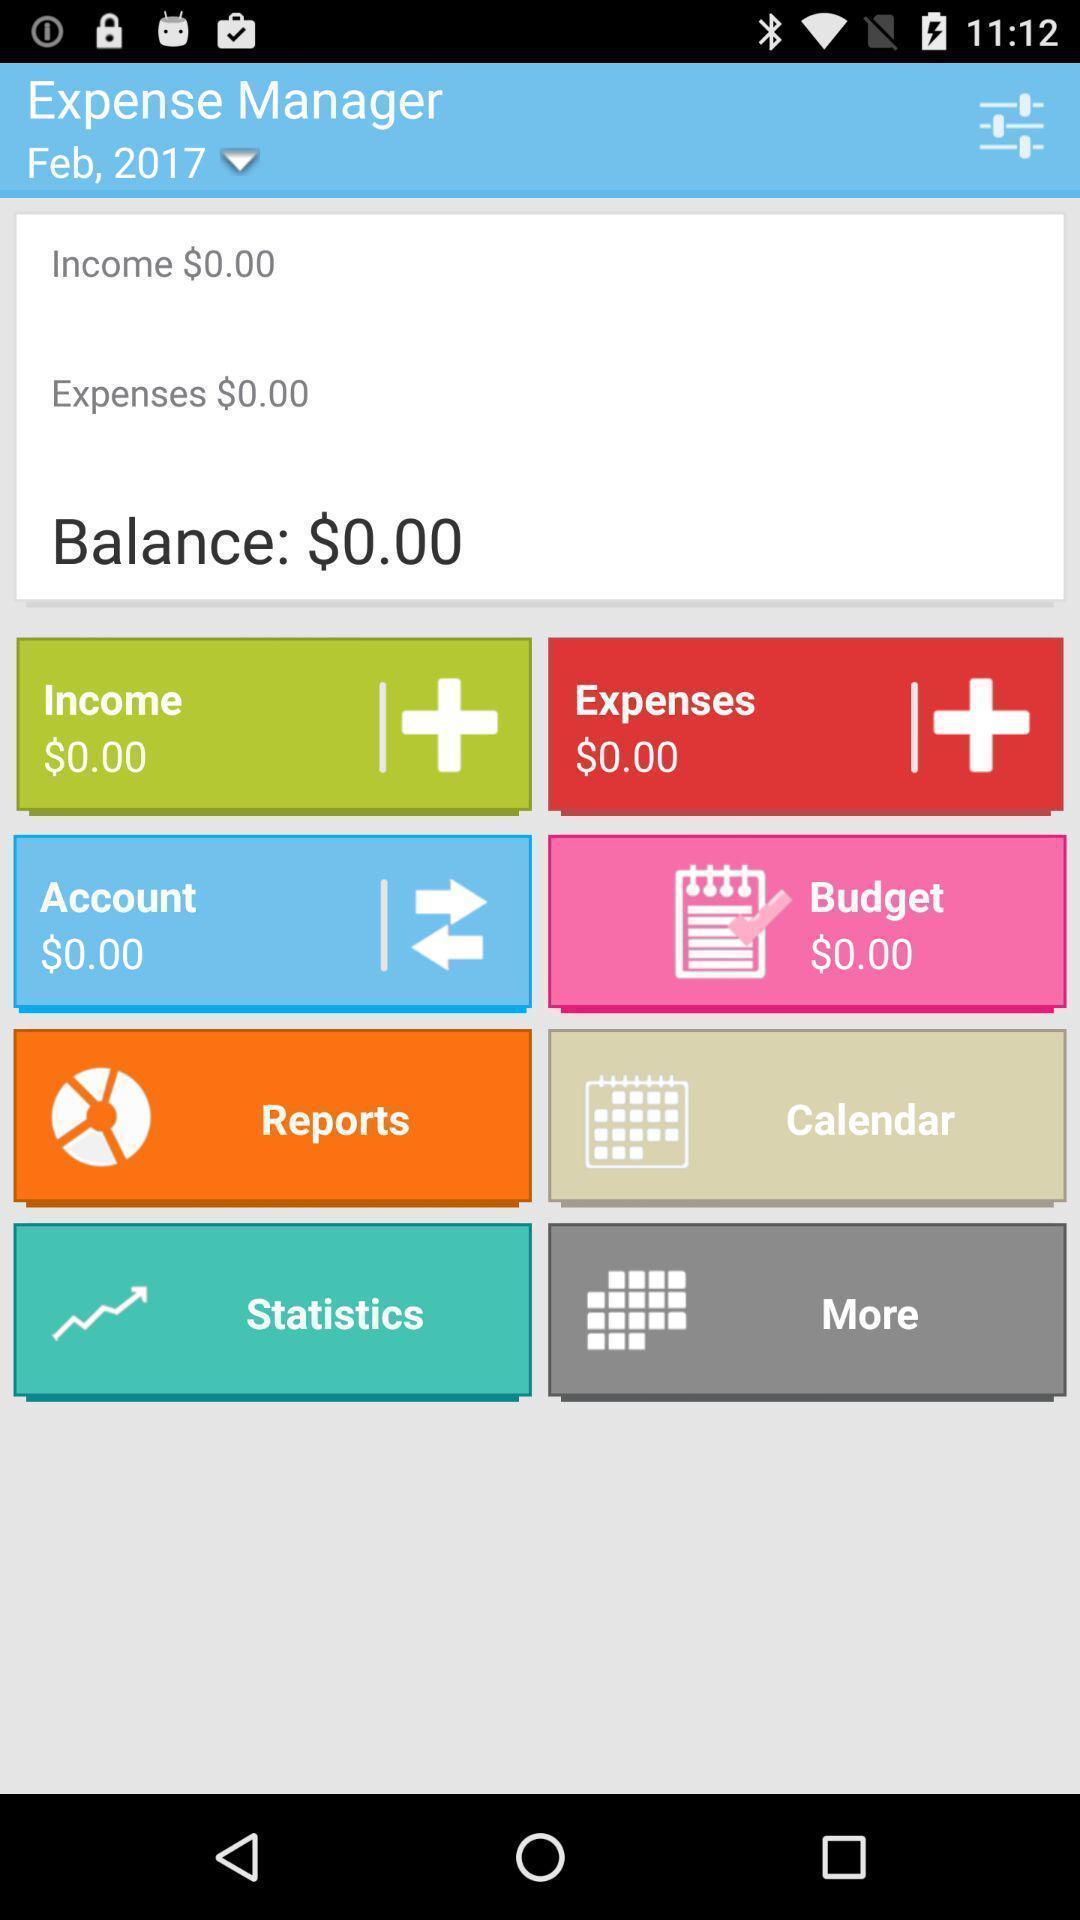What is the overall content of this screenshot? Page showing about expenses and balance. 